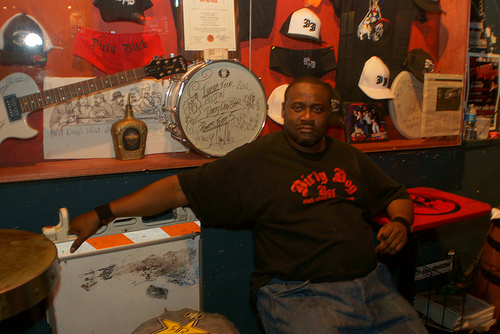<image>
Can you confirm if the man is under the drum? No. The man is not positioned under the drum. The vertical relationship between these objects is different. 